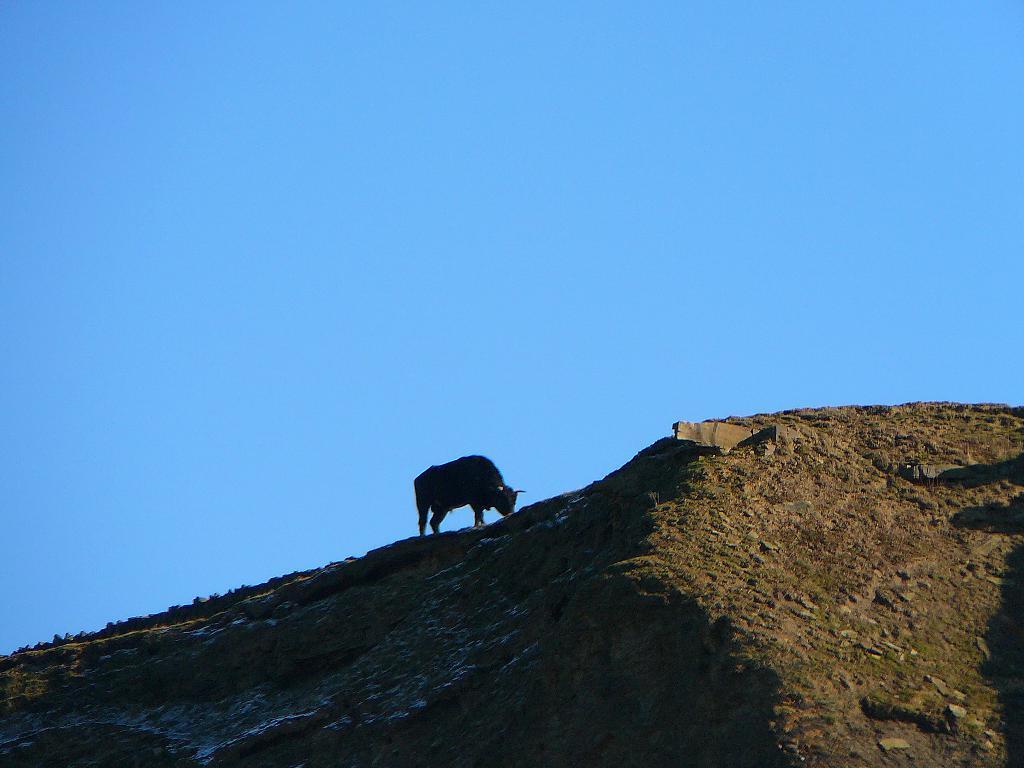Can you describe this image briefly? In this picture, there is a hill with grass. On the hill, there is an animal. On the top, there is a sky. 